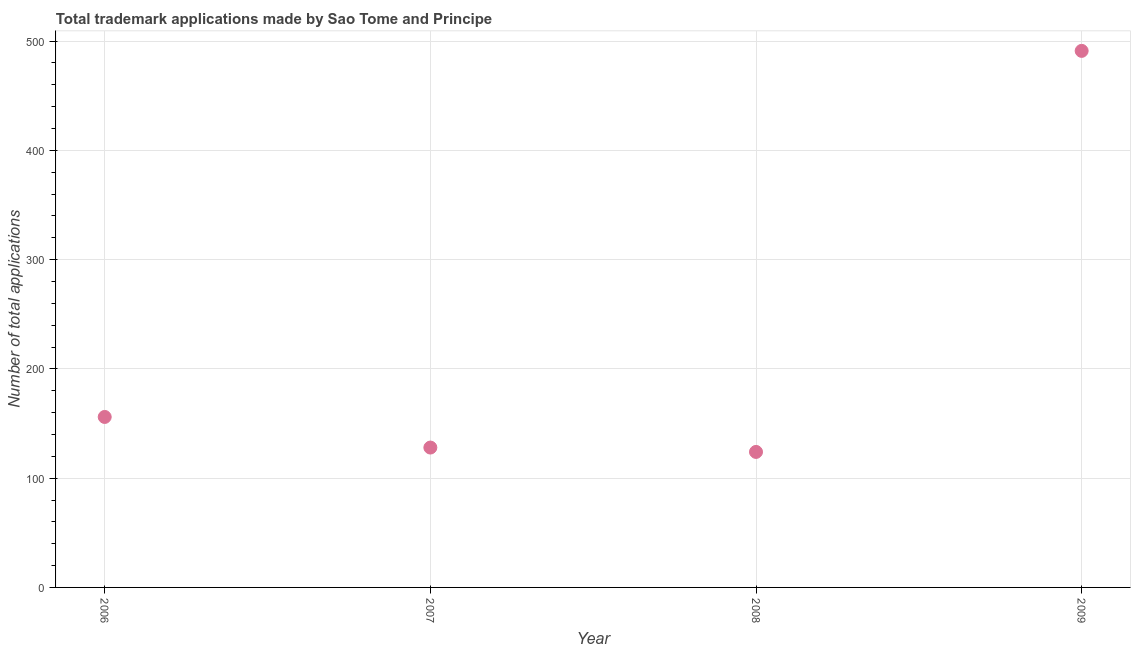What is the number of trademark applications in 2006?
Offer a terse response. 156. Across all years, what is the maximum number of trademark applications?
Provide a succinct answer. 491. Across all years, what is the minimum number of trademark applications?
Your answer should be compact. 124. In which year was the number of trademark applications maximum?
Your response must be concise. 2009. What is the sum of the number of trademark applications?
Give a very brief answer. 899. What is the difference between the number of trademark applications in 2006 and 2009?
Offer a terse response. -335. What is the average number of trademark applications per year?
Your response must be concise. 224.75. What is the median number of trademark applications?
Your response must be concise. 142. Do a majority of the years between 2007 and 2008 (inclusive) have number of trademark applications greater than 220 ?
Provide a short and direct response. No. What is the ratio of the number of trademark applications in 2006 to that in 2007?
Provide a succinct answer. 1.22. Is the number of trademark applications in 2007 less than that in 2008?
Offer a terse response. No. Is the difference between the number of trademark applications in 2006 and 2007 greater than the difference between any two years?
Provide a short and direct response. No. What is the difference between the highest and the second highest number of trademark applications?
Your response must be concise. 335. Is the sum of the number of trademark applications in 2007 and 2009 greater than the maximum number of trademark applications across all years?
Your answer should be very brief. Yes. What is the difference between the highest and the lowest number of trademark applications?
Your answer should be compact. 367. In how many years, is the number of trademark applications greater than the average number of trademark applications taken over all years?
Your answer should be compact. 1. How many dotlines are there?
Your response must be concise. 1. What is the difference between two consecutive major ticks on the Y-axis?
Offer a terse response. 100. Does the graph contain grids?
Your answer should be very brief. Yes. What is the title of the graph?
Offer a terse response. Total trademark applications made by Sao Tome and Principe. What is the label or title of the X-axis?
Offer a terse response. Year. What is the label or title of the Y-axis?
Your response must be concise. Number of total applications. What is the Number of total applications in 2006?
Offer a very short reply. 156. What is the Number of total applications in 2007?
Offer a very short reply. 128. What is the Number of total applications in 2008?
Your answer should be very brief. 124. What is the Number of total applications in 2009?
Your answer should be compact. 491. What is the difference between the Number of total applications in 2006 and 2007?
Your answer should be compact. 28. What is the difference between the Number of total applications in 2006 and 2008?
Ensure brevity in your answer.  32. What is the difference between the Number of total applications in 2006 and 2009?
Make the answer very short. -335. What is the difference between the Number of total applications in 2007 and 2008?
Offer a very short reply. 4. What is the difference between the Number of total applications in 2007 and 2009?
Give a very brief answer. -363. What is the difference between the Number of total applications in 2008 and 2009?
Your response must be concise. -367. What is the ratio of the Number of total applications in 2006 to that in 2007?
Your answer should be compact. 1.22. What is the ratio of the Number of total applications in 2006 to that in 2008?
Your answer should be very brief. 1.26. What is the ratio of the Number of total applications in 2006 to that in 2009?
Offer a terse response. 0.32. What is the ratio of the Number of total applications in 2007 to that in 2008?
Provide a short and direct response. 1.03. What is the ratio of the Number of total applications in 2007 to that in 2009?
Provide a short and direct response. 0.26. What is the ratio of the Number of total applications in 2008 to that in 2009?
Your answer should be compact. 0.25. 